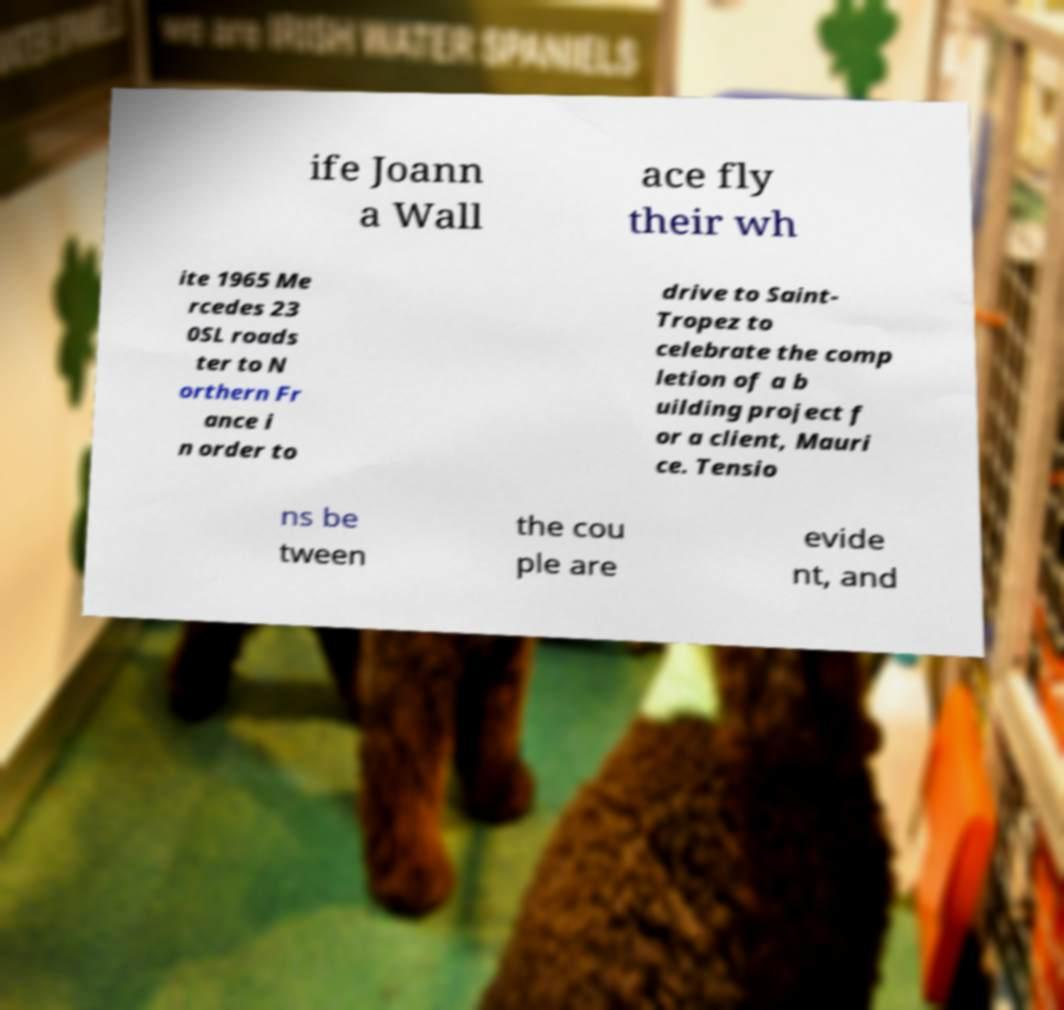I need the written content from this picture converted into text. Can you do that? ife Joann a Wall ace fly their wh ite 1965 Me rcedes 23 0SL roads ter to N orthern Fr ance i n order to drive to Saint- Tropez to celebrate the comp letion of a b uilding project f or a client, Mauri ce. Tensio ns be tween the cou ple are evide nt, and 